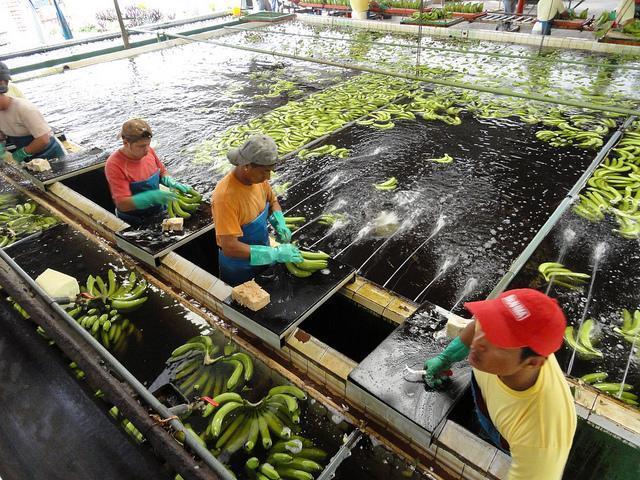How many bananas are visible?
Give a very brief answer. 4. How many people are there?
Give a very brief answer. 4. 